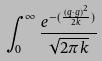<formula> <loc_0><loc_0><loc_500><loc_500>\int _ { 0 } ^ { \infty } \frac { e ^ { - ( \frac { ( q \cdot g ) ^ { 2 } } { 2 k } ) } } { \sqrt { 2 \pi k } }</formula> 